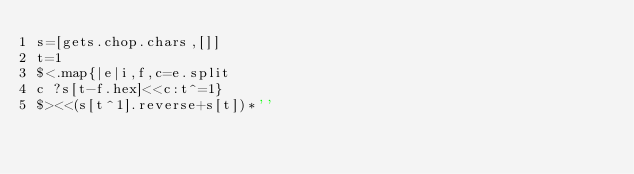Convert code to text. <code><loc_0><loc_0><loc_500><loc_500><_Ruby_>s=[gets.chop.chars,[]]
t=1
$<.map{|e|i,f,c=e.split
c ?s[t-f.hex]<<c:t^=1}
$><<(s[t^1].reverse+s[t])*''</code> 